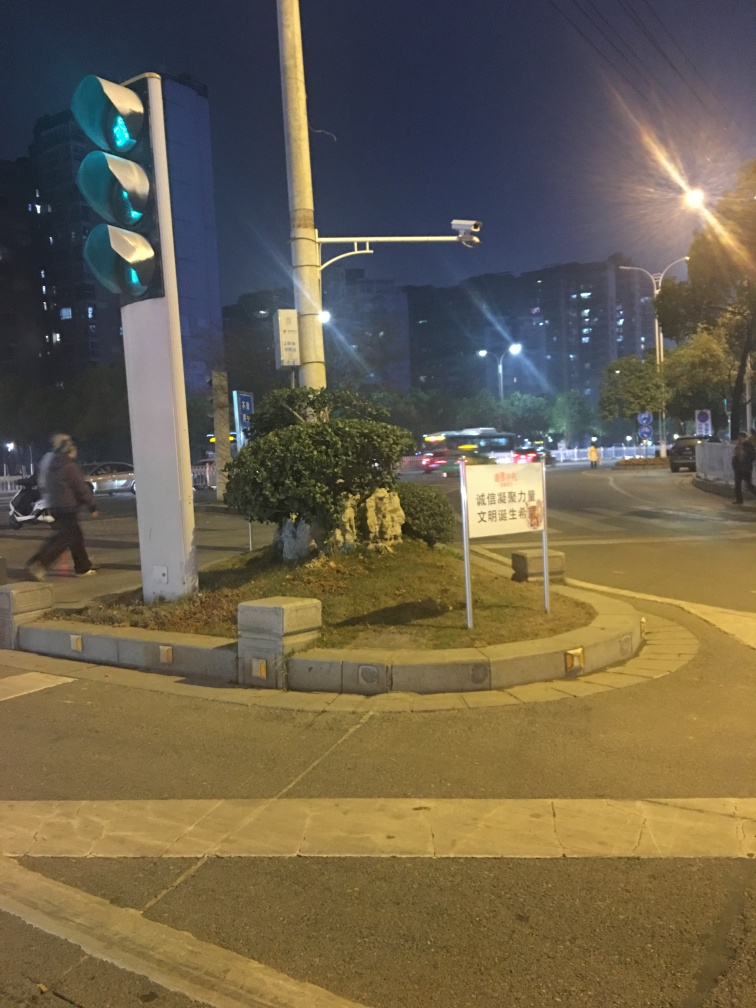What does the sign in the foreground tell us about the location or rules? The sign, although not entirely legible, appears to contain characters that suggest the image was taken in a location where Chinese is used, potentially indicating traffic rules or directions relevant to the area. Can we deduce anything about the behavior or actions of the person visible in the image? The person in the image appears to be walking, captured in mid-stride, which implies pedestrian movement in the vicinity of the traffic light, likely crossing the street. 